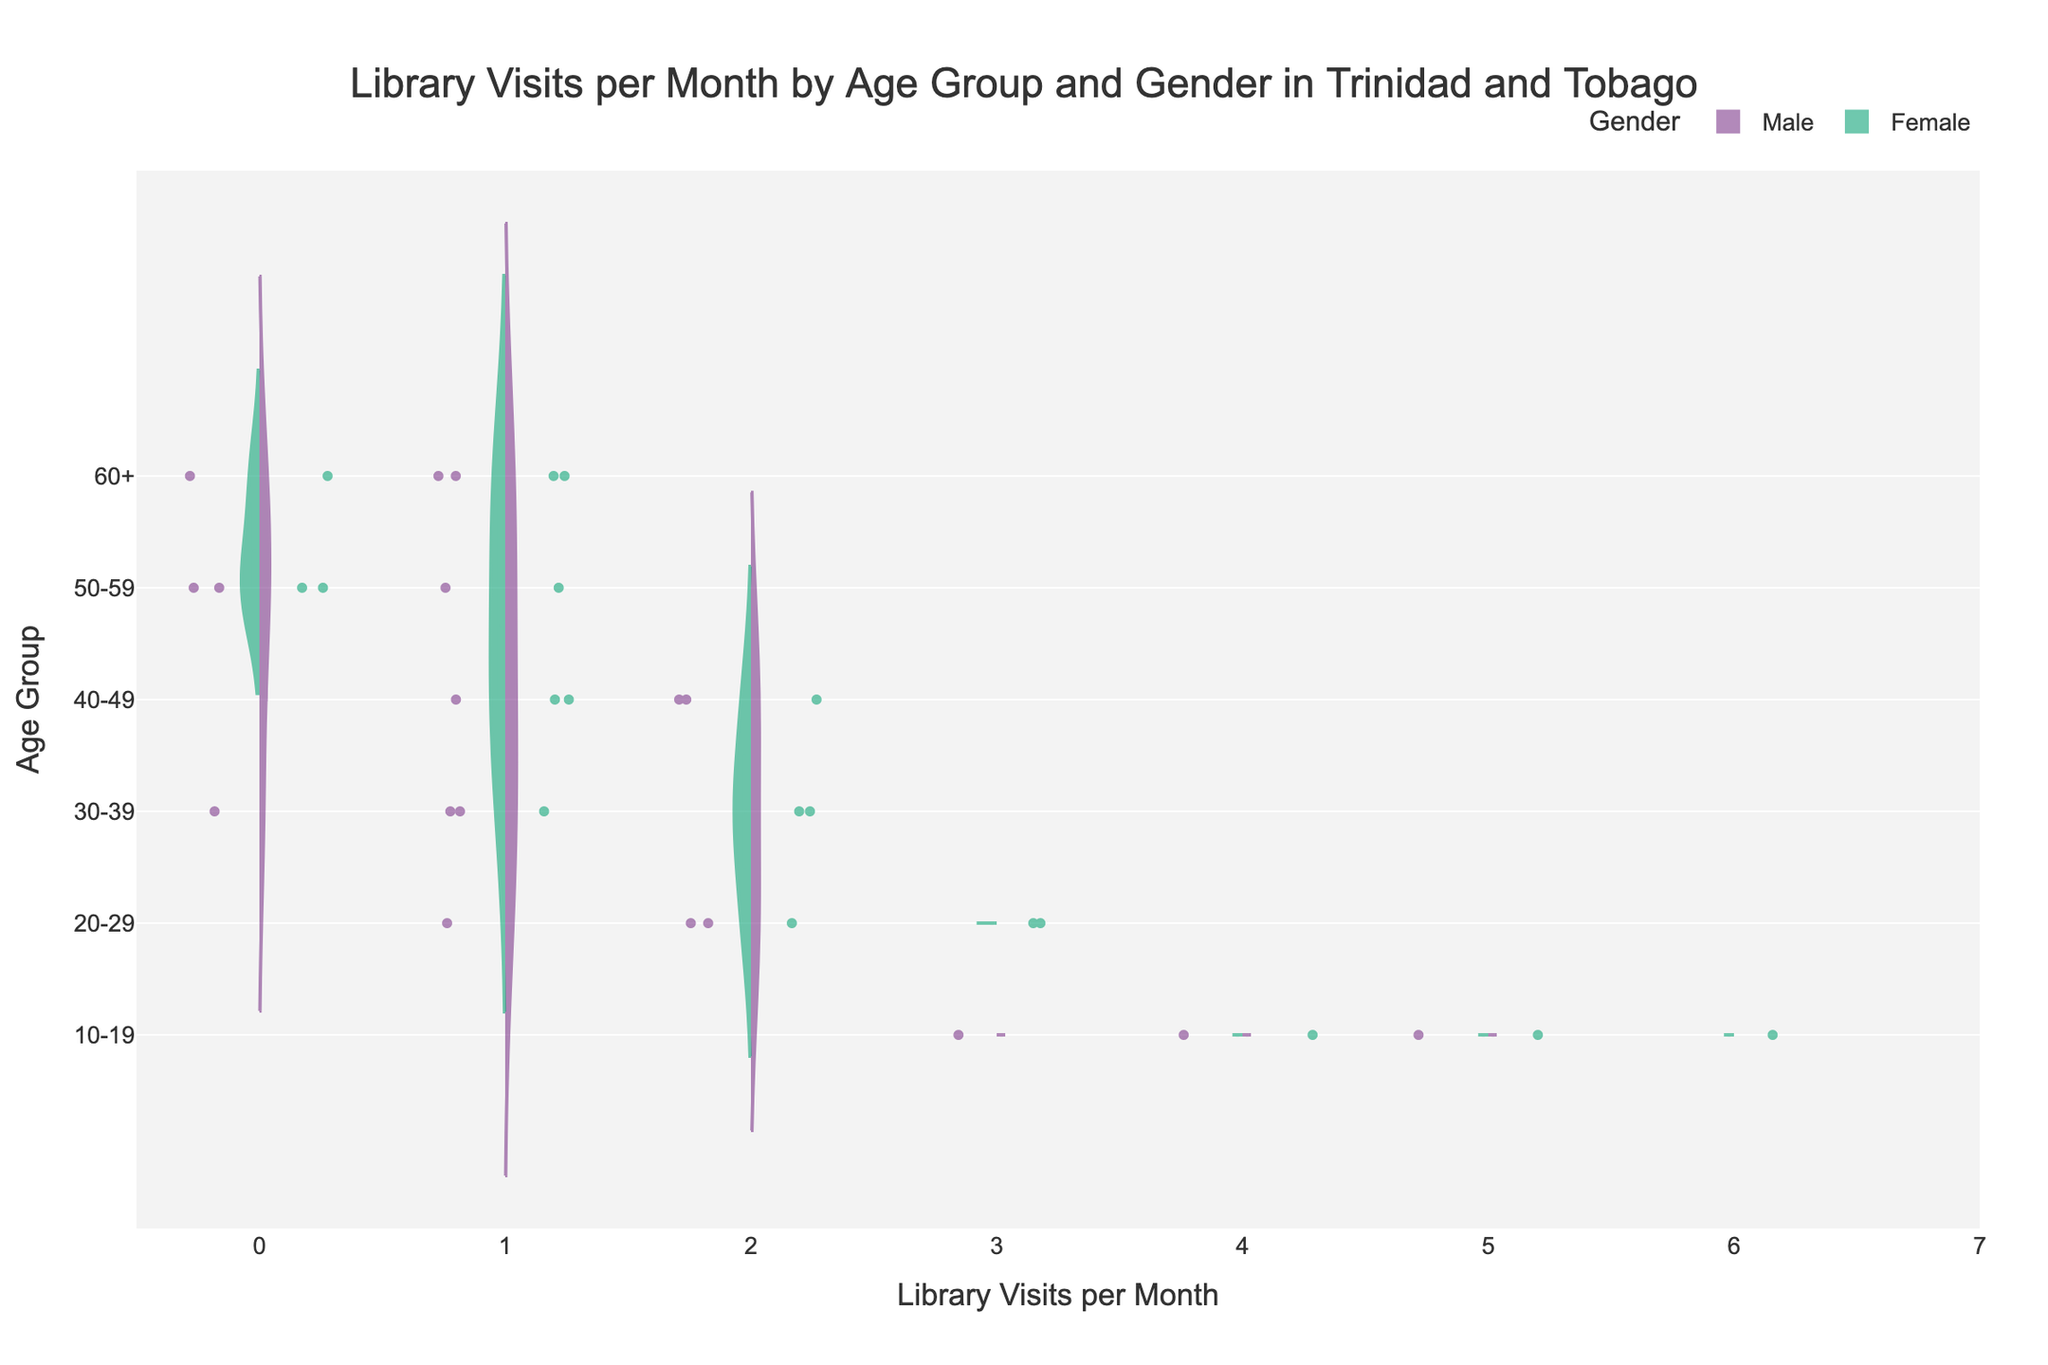What is the title of the figure? The title is displayed at the top center of the figure and describes what the chart is about.
Answer: Library Visits per Month by Age Group and Gender in Trinidad and Tobago Which gender has a higher frequency of library visits among the age group 10-19? By examining the violin plots for the age group 10-19, the density for Females indicates a higher frequency of visits compared to Males.
Answer: Female How many age groups are analyzed in this figure? The y-axis of the chart shows the distinct age groups analyzed. Counting them gives the total number of age groups.
Answer: 6 What is the maximum number of library visits per month represented in this chart? By analyzing the x-axis, the highest value depicted is the maximum number of library visits per month.
Answer: 6 Which age group has the lowest median library visits for males? By examining the box plots within the violins for each age group, we notice that for males, the age group 50-59 has the lowest median, indicated by the middle line of the box plot.
Answer: 50-59 What is the average number of library visits per month for females in the age group 20-29? Calculate the mean of the points shown in the violin plot for females aged 20-29. The average number of visits is (3+3+2)/3 = 2.67.
Answer: 2.67 In which age group do males and females have almost the same median number of library visits? By comparing the medians (middle lines in the box plots) within each age group, both the 40-49 and 60+ age groups display similar median library visits for both genders.
Answer: 40-49 and 60+ Which age group exhibits the most variation in library visits for males? Look at the width of the violin plots for males across different age groups. The group 10-19 shows the greatest spread, indicating higher variation in library visits.
Answer: 10-19 Are there any age groups where no library visits were recorded for males within a month? Check the points within the violin plots for males. The age group 30-39 and 50-59 have points with zero library visits per month.
Answer: Yes, 30-39 and 50-59 How does the total count of data points for females compare to that for males within the 10-19 age group? By counting the individual points (jittered) within the violin plots for each gender in the 10-19 age group, there are 3 points for males and 3 points for females. Both have the same count.
Answer: They are the same 